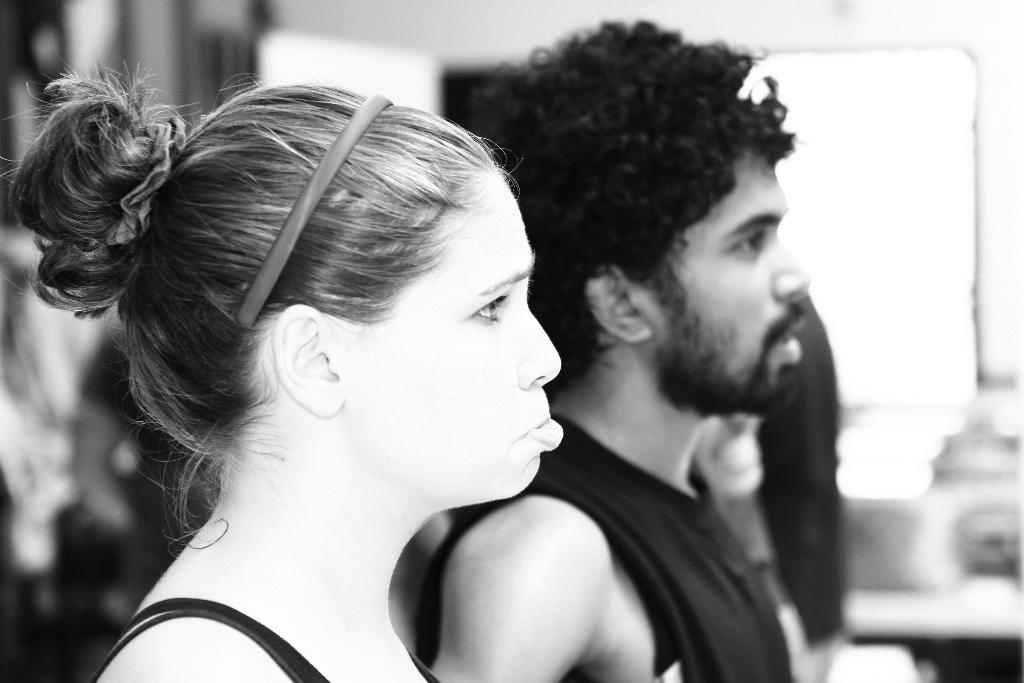How many people are in the image wearing dresses? There are two people with dresses in the image. Can you describe any accessories worn by the people in the image? One person is wearing a hair band. What can be said about the background of the image? The background of the image is blurred. What is the color scheme of the image? The image is in black and white. What type of bells can be heard ringing in the image? There are no bells present in the image, and therefore no sound can be heard. What type of shock is depicted in the image? There is no shock depicted in the image; it features two people wearing dresses and a blurred background. 